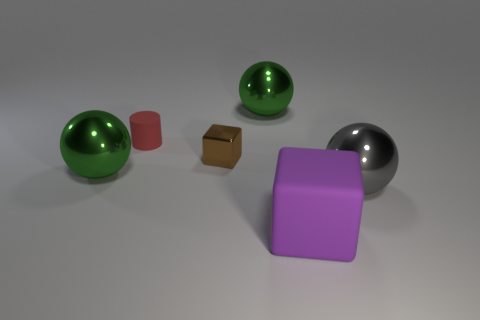How big is the green ball that is left of the small thing to the left of the small shiny cube?
Offer a very short reply. Large. There is a large purple thing that is the same shape as the tiny brown thing; what material is it?
Provide a succinct answer. Rubber. Is the purple thing the same size as the matte cylinder?
Make the answer very short. No. How big is the shiny sphere that is on the right side of the small red cylinder and behind the big gray sphere?
Keep it short and to the point. Large. Is the large rubber cube the same color as the cylinder?
Provide a short and direct response. No. How big is the green metallic thing to the left of the tiny red cylinder?
Ensure brevity in your answer.  Large. Is the number of large gray balls that are on the left side of the small red object the same as the number of tiny metallic blocks that are left of the big purple rubber block?
Provide a short and direct response. No. Does the cube that is behind the gray thing have the same material as the big green sphere that is in front of the brown thing?
Make the answer very short. Yes. What number of other things are the same size as the gray ball?
Provide a succinct answer. 3. How many things are either cyan matte things or big balls on the left side of the big matte thing?
Provide a succinct answer. 2. 